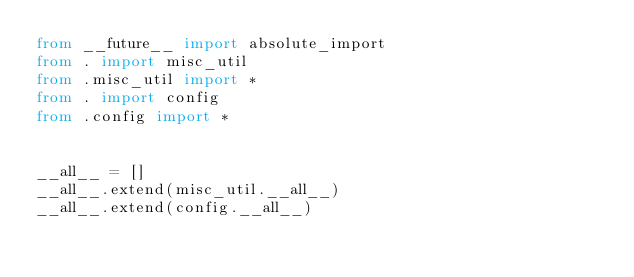<code> <loc_0><loc_0><loc_500><loc_500><_Python_>from __future__ import absolute_import
from . import misc_util
from .misc_util import *
from . import config
from .config import *


__all__ = []
__all__.extend(misc_util.__all__)
__all__.extend(config.__all__)
</code> 